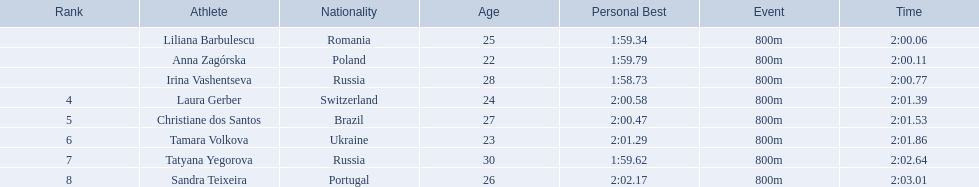What are the names of the competitors? Liliana Barbulescu, Anna Zagórska, Irina Vashentseva, Laura Gerber, Christiane dos Santos, Tamara Volkova, Tatyana Yegorova, Sandra Teixeira. Which finalist finished the fastest? Liliana Barbulescu. 